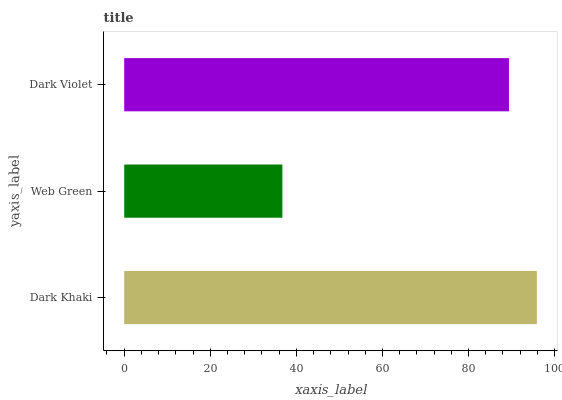Is Web Green the minimum?
Answer yes or no. Yes. Is Dark Khaki the maximum?
Answer yes or no. Yes. Is Dark Violet the minimum?
Answer yes or no. No. Is Dark Violet the maximum?
Answer yes or no. No. Is Dark Violet greater than Web Green?
Answer yes or no. Yes. Is Web Green less than Dark Violet?
Answer yes or no. Yes. Is Web Green greater than Dark Violet?
Answer yes or no. No. Is Dark Violet less than Web Green?
Answer yes or no. No. Is Dark Violet the high median?
Answer yes or no. Yes. Is Dark Violet the low median?
Answer yes or no. Yes. Is Dark Khaki the high median?
Answer yes or no. No. Is Web Green the low median?
Answer yes or no. No. 